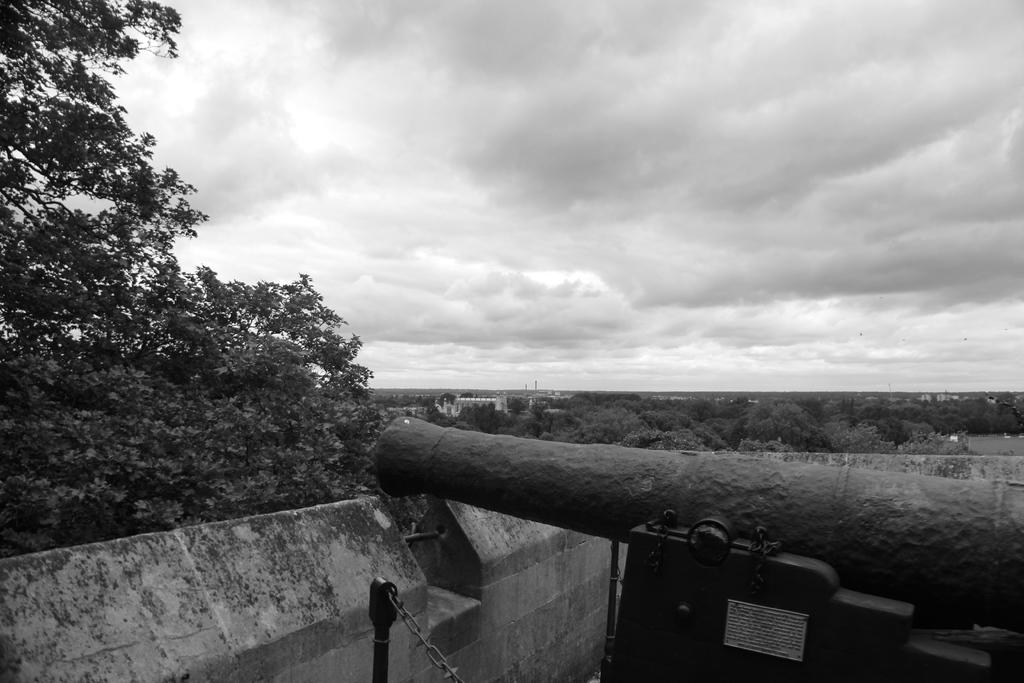What is the main object in the image? There is a cannon in the image. What is located behind the cannon? There is there a wall in the image? What other natural elements can be seen in the image? There is a tree in the image. What can be seen in the background of the image? There are trees visible in the background of the image. How would you describe the weather based on the image? The sky is cloudy in the image. How many cherries are on the tray next to the cannon in the image? There is no tray or cherries present in the image. What type of destruction is caused by the cannon in the image? There is no destruction depicted in the image; it only shows a cannon and its surroundings. 